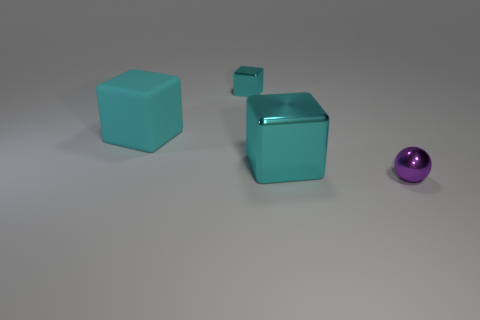How many things are matte objects on the left side of the small cyan object or small metallic objects that are to the right of the small cube?
Make the answer very short. 2. Are there fewer blocks than big cyan matte cubes?
Your answer should be very brief. No. There is another object that is the same size as the purple metallic object; what is it made of?
Provide a short and direct response. Metal. There is a shiny object in front of the large metallic block; is it the same size as the cyan cube that is on the left side of the small cyan shiny block?
Your answer should be compact. No. Is there a sphere made of the same material as the tiny cyan thing?
Offer a terse response. Yes. How many objects are either objects behind the tiny ball or purple metal cylinders?
Ensure brevity in your answer.  3. Is the material of the big cube that is right of the big rubber thing the same as the tiny cyan thing?
Offer a terse response. Yes. Does the purple shiny thing have the same shape as the large matte thing?
Offer a very short reply. No. How many rubber cubes are to the right of the block that is to the right of the small cyan cube?
Offer a very short reply. 0. There is a small thing that is the same shape as the big cyan shiny object; what is it made of?
Offer a terse response. Metal. 